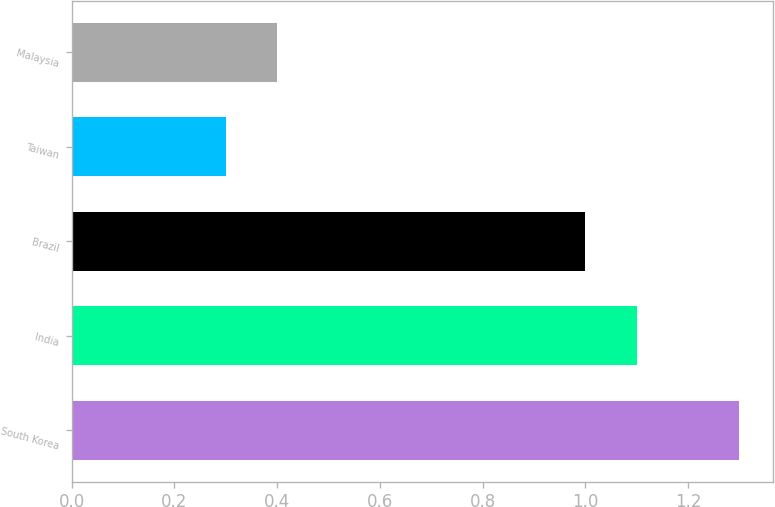Convert chart. <chart><loc_0><loc_0><loc_500><loc_500><bar_chart><fcel>South Korea<fcel>India<fcel>Brazil<fcel>Taiwan<fcel>Malaysia<nl><fcel>1.3<fcel>1.1<fcel>1<fcel>0.3<fcel>0.4<nl></chart> 